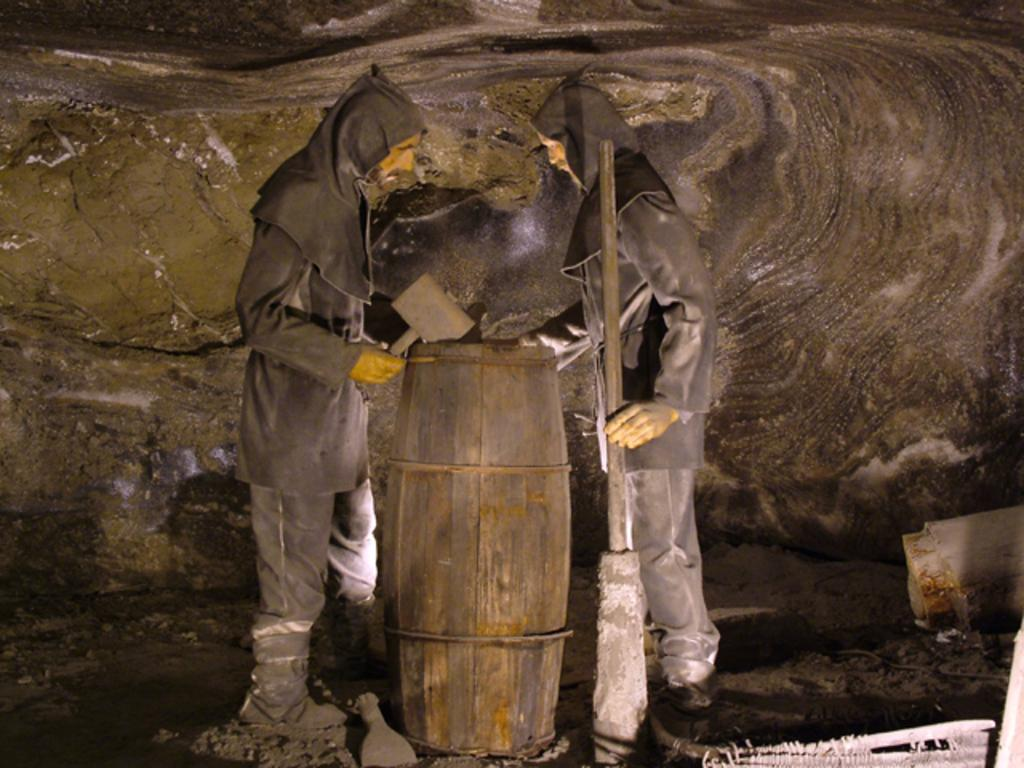How many people are in the image? There are two men in the image. What are the men wearing? The men are wearing black color dress. What object can be seen near the men? The men are standing near a wooden drum. What are the men holding in their hands? The men are holding something in their hands. What type of food is the men testing in the image? There is no food present in the image, nor is there any indication that the men are testing anything. 